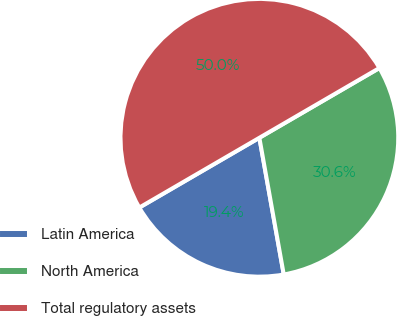Convert chart to OTSL. <chart><loc_0><loc_0><loc_500><loc_500><pie_chart><fcel>Latin America<fcel>North America<fcel>Total regulatory assets<nl><fcel>19.43%<fcel>30.57%<fcel>50.0%<nl></chart> 